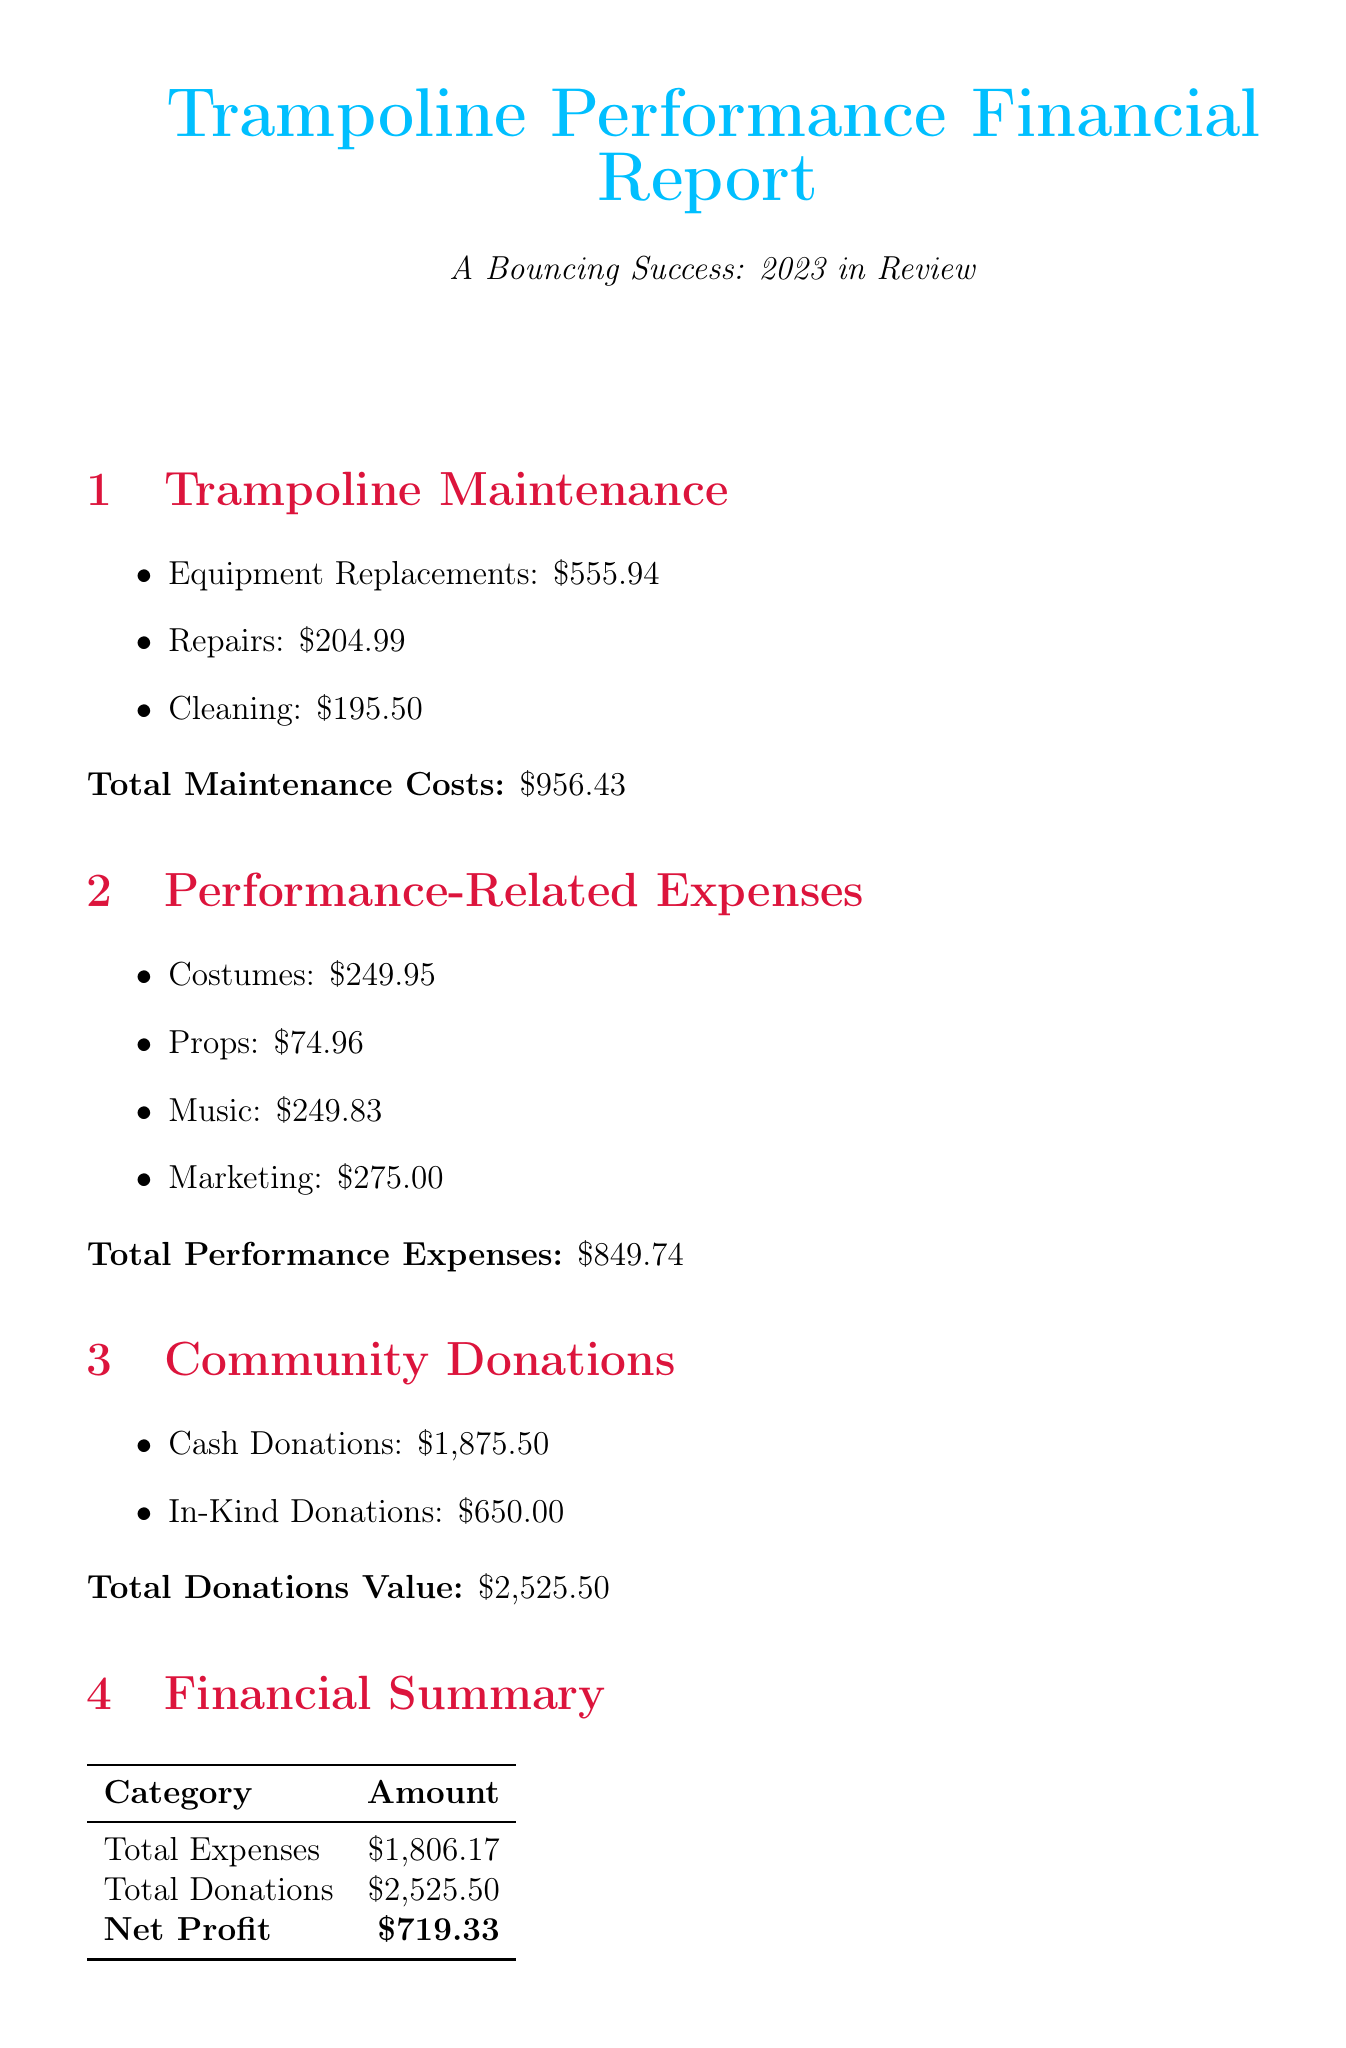What are the total trampoline maintenance costs? The total maintenance costs are stated explicitly in the summary section of the report.
Answer: $956.43 How much was spent on performance-related expenses? This figure is clearly provided in the performance-related expenses section of the document.
Answer: $849.74 What was the total amount of cash donations received? The total cash donations are directly mentioned in the community donations section.
Answer: $1,875.50 What is the estimated cost for the professional-grade rectangular trampoline? The cost is listed under the future plans section concerning equipment upgrades.
Answer: $2,999.00 What is the total value of community donations? The total donations value is summarized after listing both cash and in-kind donations.
Answer: $2,525.50 What was the net profit for the year 2023? The net profit is calculated and stated in the financial summary table at the end of the report.
Answer: $719.33 Which organization contributed the highest amount in cash donations? The source with the highest contribution is mentioned in the breakdown of cash donations under community donations.
Answer: local business sponsors How much was spent on costumes? The total spending on costumes is detailed in the performance-related expenses section.
Answer: $249.95 What was the total expenses incurred for the year? The total expenses are clearly outlined in the financial summary section of the document.
Answer: $1,806.17 